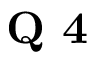<formula> <loc_0><loc_0><loc_500><loc_500>Q 4</formula> 